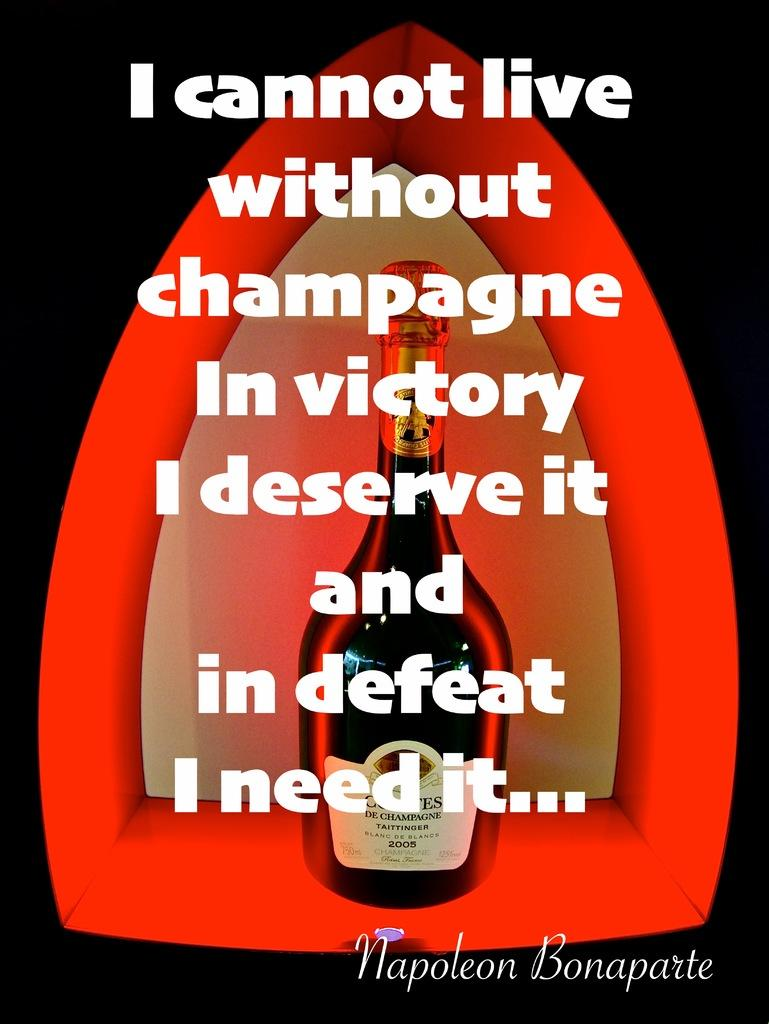<image>
Create a compact narrative representing the image presented. the word victory that is on a wine bottle 